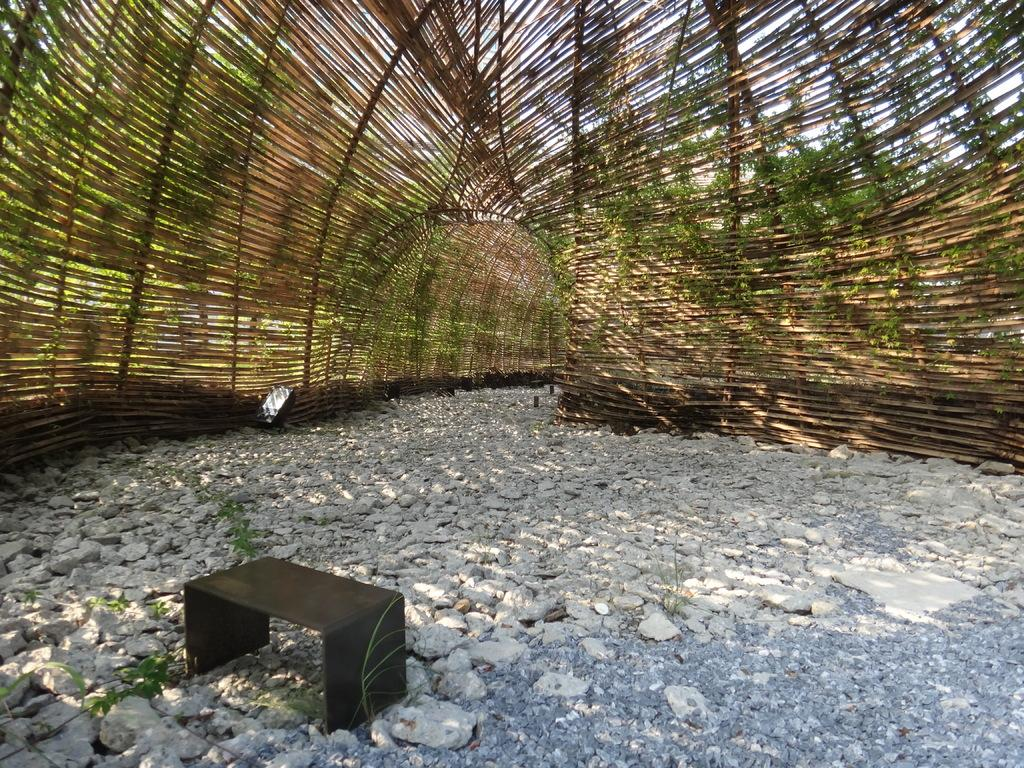What type of surface can be seen in the image? There is a path in the image. What is covering the path in the image? The path is under a shed. What type of material is present on the ground in the image? There are stones in the image. What type of furniture is visible in the image? There is a small table in the image. What type of vegetation is present in the image? There are trees in the image. What is visible above the shed and trees in the image? The sky is visible in the image. What type of jail is depicted in the image? There is no jail present in the image. Who is the governor representing in the image? There is no governor or representative present in the image. 